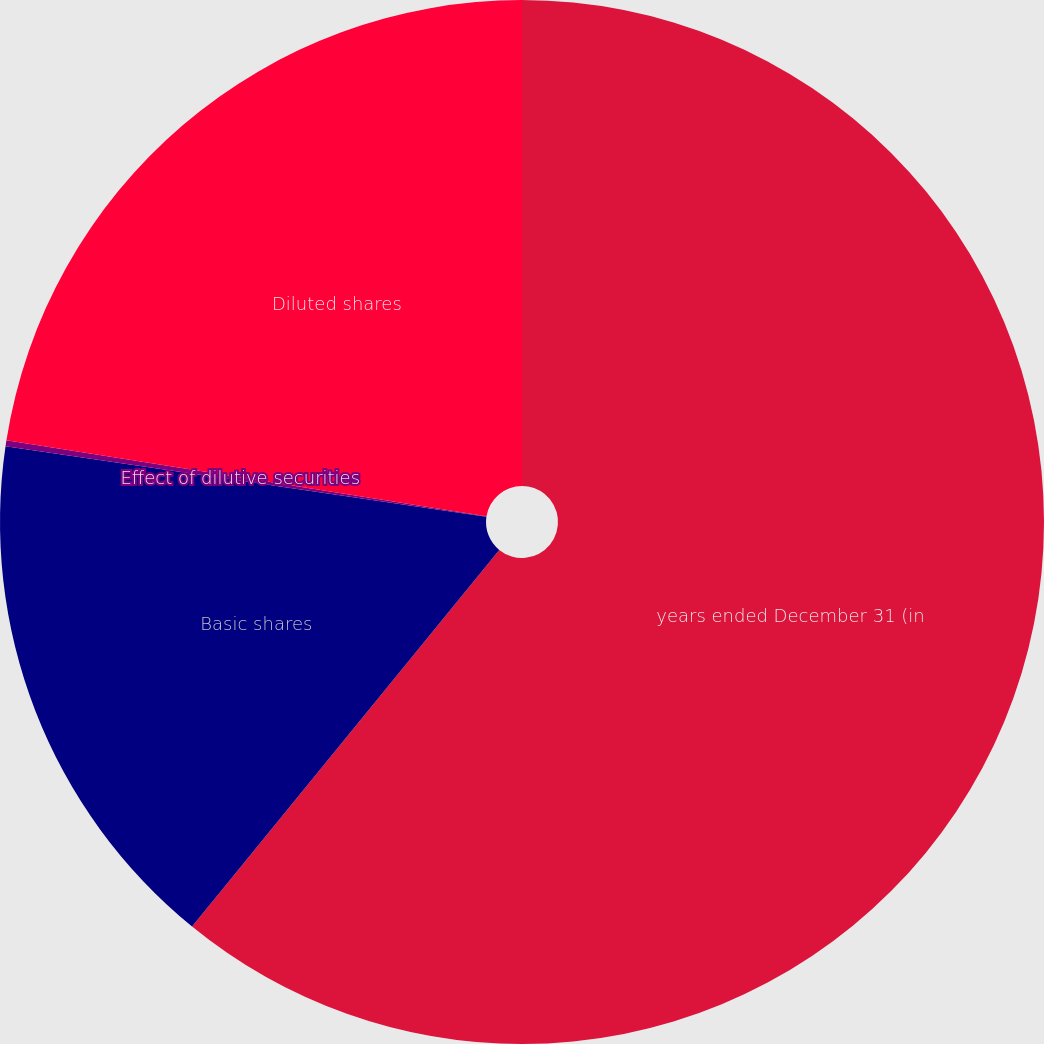<chart> <loc_0><loc_0><loc_500><loc_500><pie_chart><fcel>years ended December 31 (in<fcel>Basic shares<fcel>Effect of dilutive securities<fcel>Diluted shares<nl><fcel>60.89%<fcel>16.43%<fcel>0.18%<fcel>22.5%<nl></chart> 